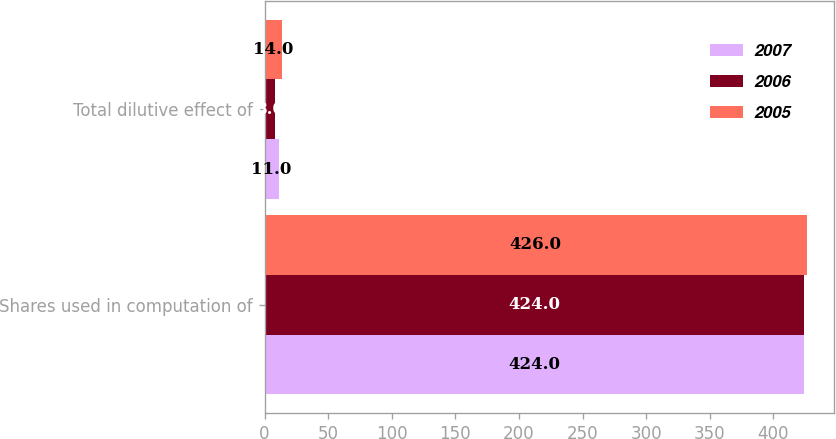Convert chart to OTSL. <chart><loc_0><loc_0><loc_500><loc_500><stacked_bar_chart><ecel><fcel>Shares used in computation of<fcel>Total dilutive effect of<nl><fcel>2007<fcel>424<fcel>11<nl><fcel>2006<fcel>424<fcel>8<nl><fcel>2005<fcel>426<fcel>14<nl></chart> 